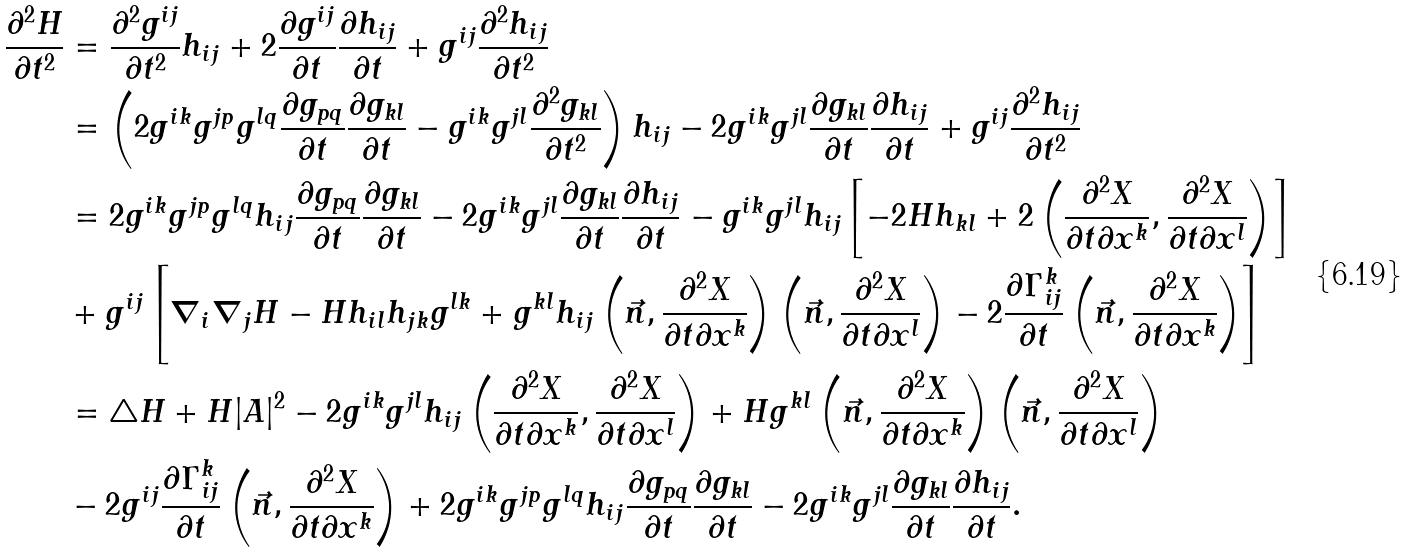<formula> <loc_0><loc_0><loc_500><loc_500>\frac { \partial ^ { 2 } H } { \partial t ^ { 2 } } & = \frac { \partial ^ { 2 } g ^ { i j } } { \partial t ^ { 2 } } h _ { i j } + 2 \frac { \partial g ^ { i j } } { \partial t } \frac { \partial h _ { i j } } { \partial t } + g ^ { i j } \frac { \partial ^ { 2 } h _ { i j } } { \partial t ^ { 2 } } \\ & = \left ( 2 g ^ { i k } g ^ { j p } g ^ { l q } \frac { \partial g _ { p q } } { \partial t } \frac { \partial g _ { k l } } { \partial t } - g ^ { i k } g ^ { j l } \frac { \partial ^ { 2 } g _ { k l } } { \partial t ^ { 2 } } \right ) h _ { i j } - 2 g ^ { i k } g ^ { j l } \frac { \partial g _ { k l } } { \partial t } \frac { \partial h _ { i j } } { \partial t } + g ^ { i j } \frac { \partial ^ { 2 } h _ { i j } } { \partial t ^ { 2 } } \\ & = 2 g ^ { i k } g ^ { j p } g ^ { l q } h _ { i j } \frac { \partial g _ { p q } } { \partial t } \frac { \partial g _ { k l } } { \partial t } - 2 g ^ { i k } g ^ { j l } \frac { \partial g _ { k l } } { \partial t } \frac { \partial h _ { i j } } { \partial t } - g ^ { i k } g ^ { j l } h _ { i j } \left [ - 2 H h _ { k l } + 2 \left ( \frac { \partial ^ { 2 } X } { \partial t \partial x ^ { k } } , \frac { \partial ^ { 2 } X } { \partial t \partial x ^ { l } } \right ) \right ] \\ & + g ^ { i j } \left [ \nabla _ { i } \nabla _ { j } H - H h _ { i l } h _ { j k } g ^ { l k } + g ^ { k l } h _ { i j } \left ( \vec { n } , \frac { \partial ^ { 2 } X } { \partial t \partial x ^ { k } } \right ) \left ( \vec { n } , \frac { \partial ^ { 2 } X } { \partial t \partial x ^ { l } } \right ) - 2 \frac { \partial \Gamma ^ { k } _ { i j } } { \partial t } \left ( \vec { n } , \frac { \partial ^ { 2 } X } { \partial t \partial x ^ { k } } \right ) \right ] \\ & = \bigtriangleup H + H | A | ^ { 2 } - 2 g ^ { i k } g ^ { j l } h _ { i j } \left ( \frac { \partial ^ { 2 } X } { \partial t \partial x ^ { k } } , \frac { \partial ^ { 2 } X } { \partial t \partial x ^ { l } } \right ) + H g ^ { k l } \left ( \vec { n } , \frac { \partial ^ { 2 } X } { \partial t \partial x ^ { k } } \right ) \left ( \vec { n } , \frac { \partial ^ { 2 } X } { \partial t \partial x ^ { l } } \right ) \\ & - 2 g ^ { i j } \frac { \partial \Gamma ^ { k } _ { i j } } { \partial t } \left ( \vec { n } , \frac { \partial ^ { 2 } X } { \partial t \partial x ^ { k } } \right ) + 2 g ^ { i k } g ^ { j p } g ^ { l q } h _ { i j } \frac { \partial g _ { p q } } { \partial t } \frac { \partial g _ { k l } } { \partial t } - 2 g ^ { i k } g ^ { j l } \frac { \partial g _ { k l } } { \partial t } \frac { \partial h _ { i j } } { \partial t } .</formula> 